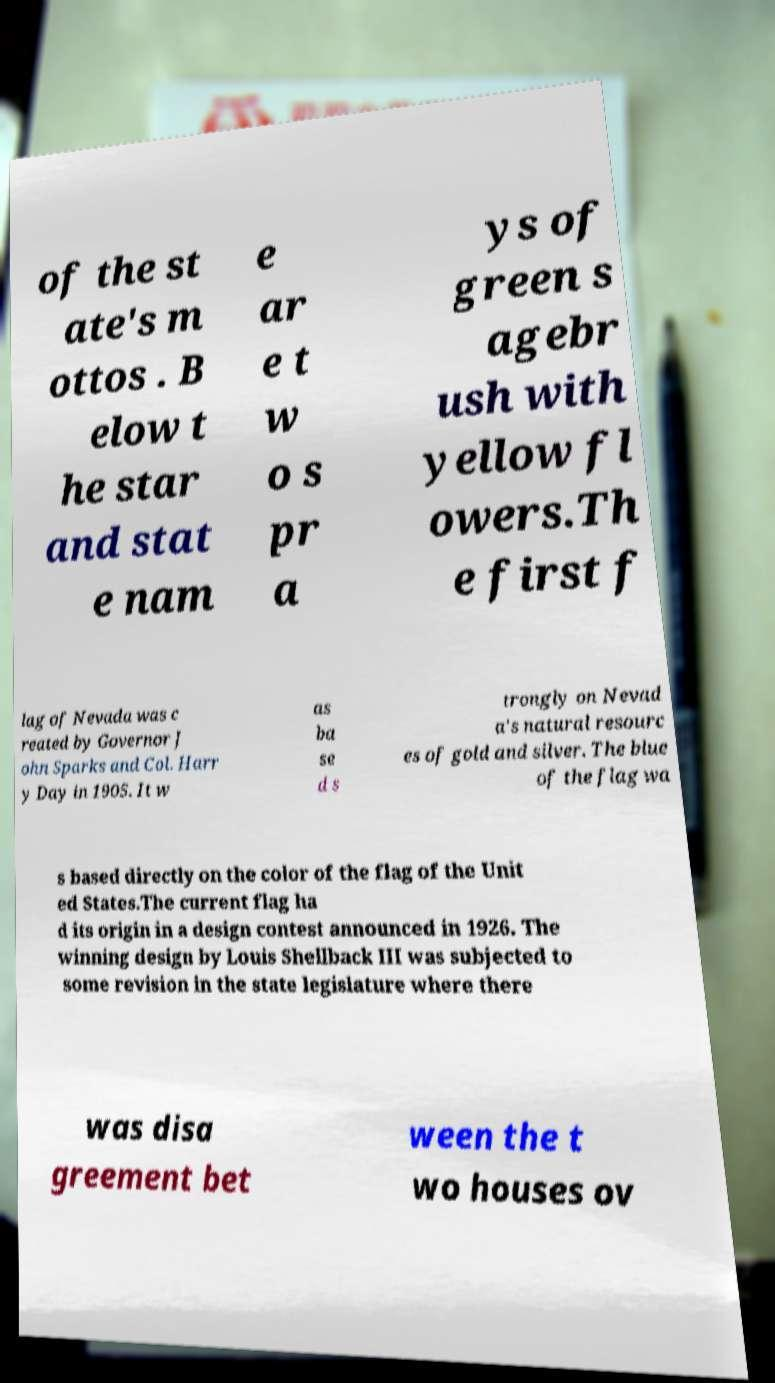Could you assist in decoding the text presented in this image and type it out clearly? of the st ate's m ottos . B elow t he star and stat e nam e ar e t w o s pr a ys of green s agebr ush with yellow fl owers.Th e first f lag of Nevada was c reated by Governor J ohn Sparks and Col. Harr y Day in 1905. It w as ba se d s trongly on Nevad a's natural resourc es of gold and silver. The blue of the flag wa s based directly on the color of the flag of the Unit ed States.The current flag ha d its origin in a design contest announced in 1926. The winning design by Louis Shellback III was subjected to some revision in the state legislature where there was disa greement bet ween the t wo houses ov 